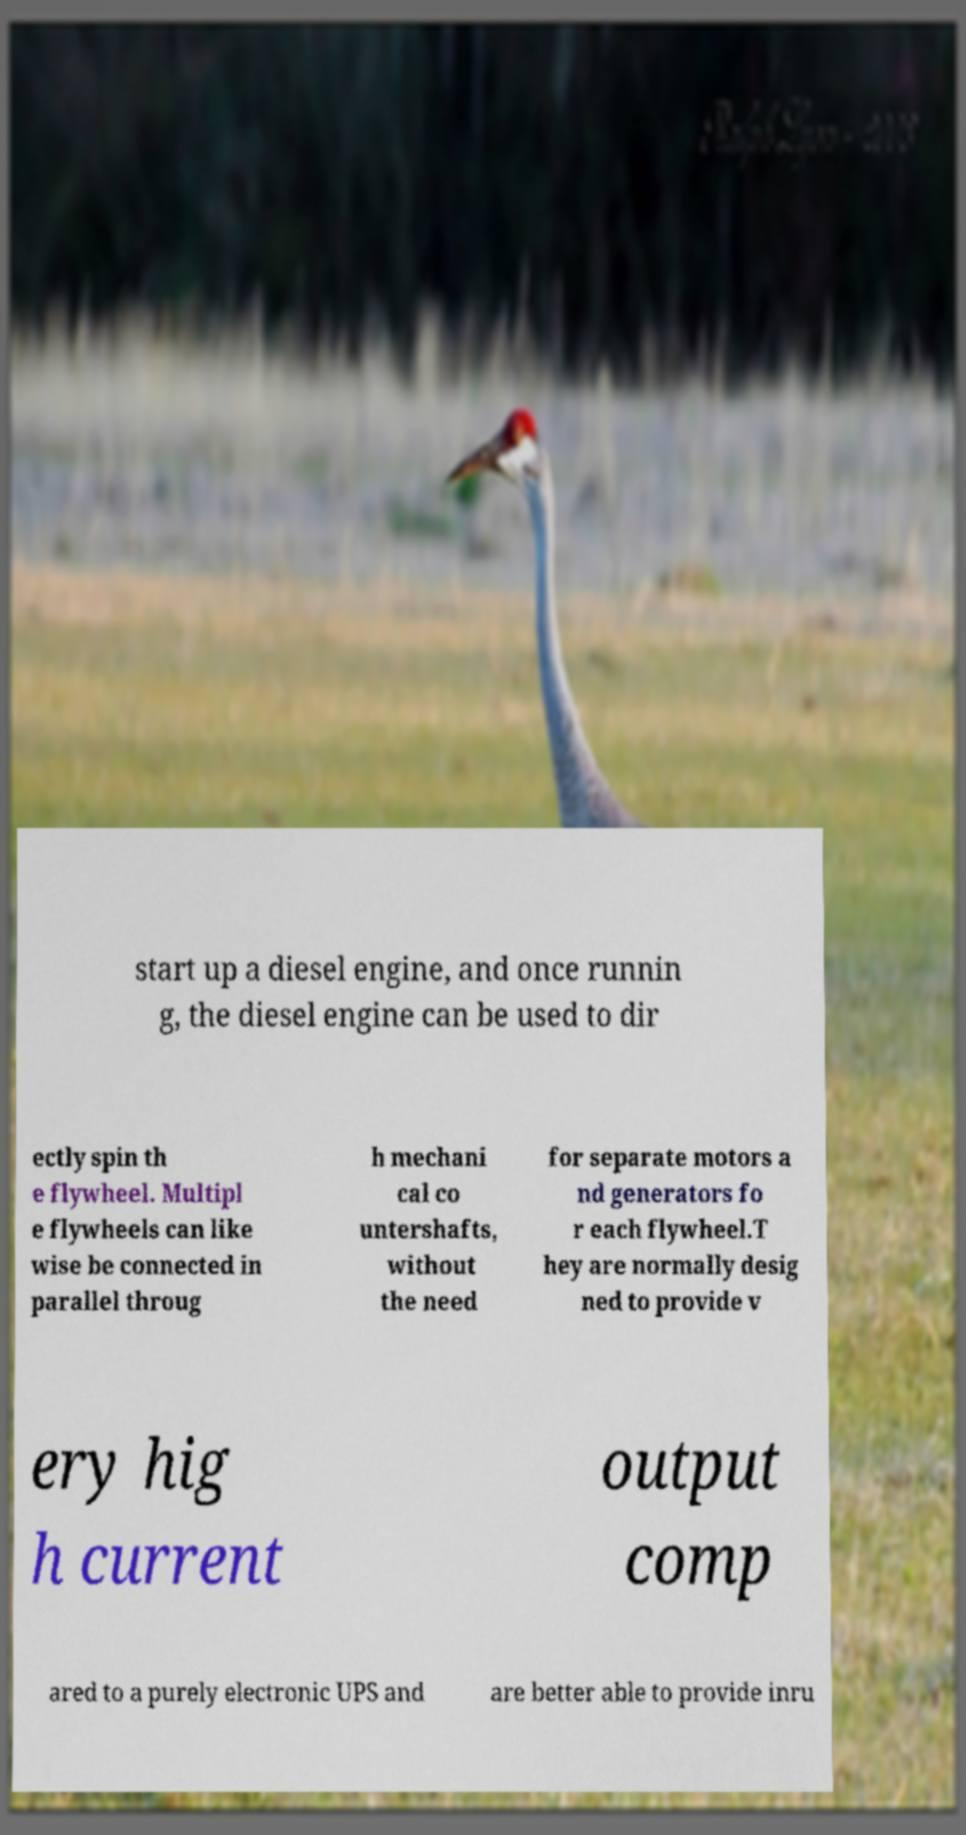Could you assist in decoding the text presented in this image and type it out clearly? start up a diesel engine, and once runnin g, the diesel engine can be used to dir ectly spin th e flywheel. Multipl e flywheels can like wise be connected in parallel throug h mechani cal co untershafts, without the need for separate motors a nd generators fo r each flywheel.T hey are normally desig ned to provide v ery hig h current output comp ared to a purely electronic UPS and are better able to provide inru 